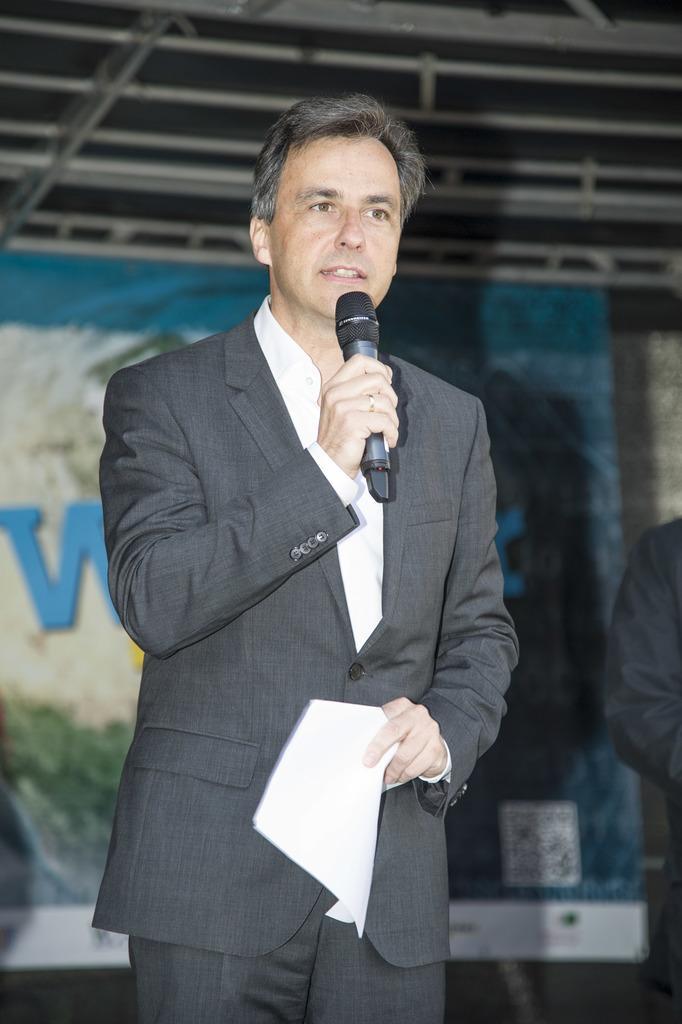In one or two sentences, can you explain what this image depicts? There is a man in the picture, holding a microphone in his hand and some papers. He's wearing a coat. He is talking. 